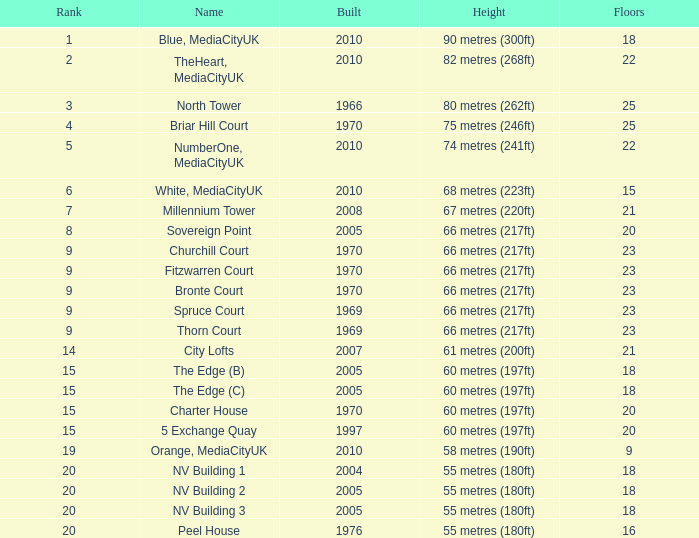What is Height, when Rank is less than 20, when Floors is greater than 9, when Built is 2005, and when Name is The Edge (C)? 60 metres (197ft). 